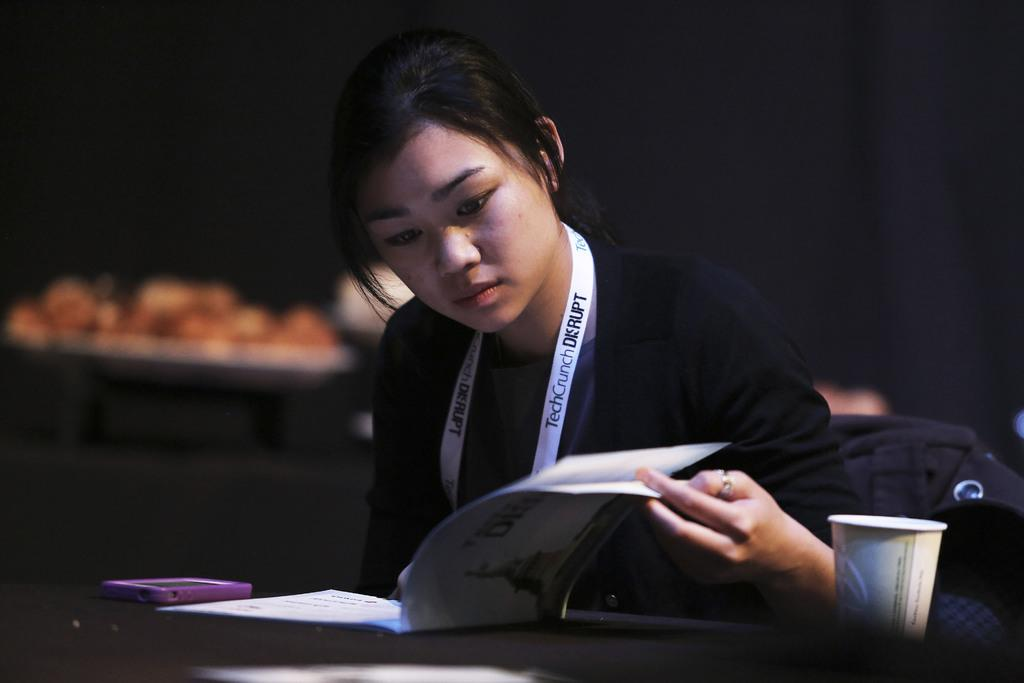Who is the main subject in the image? There is a girl in the center of the image. What is the girl doing in the image? The girl is reading a book. What is located in front of the girl? There is a table in front of the girl. What objects can be seen on the table? There is a cell phone and a glass on the table. What type of plough is being used by the girl in the image? There is no plough present in the image; the girl is reading a book. What is the position of the range in the image? There is no range present in the image. 